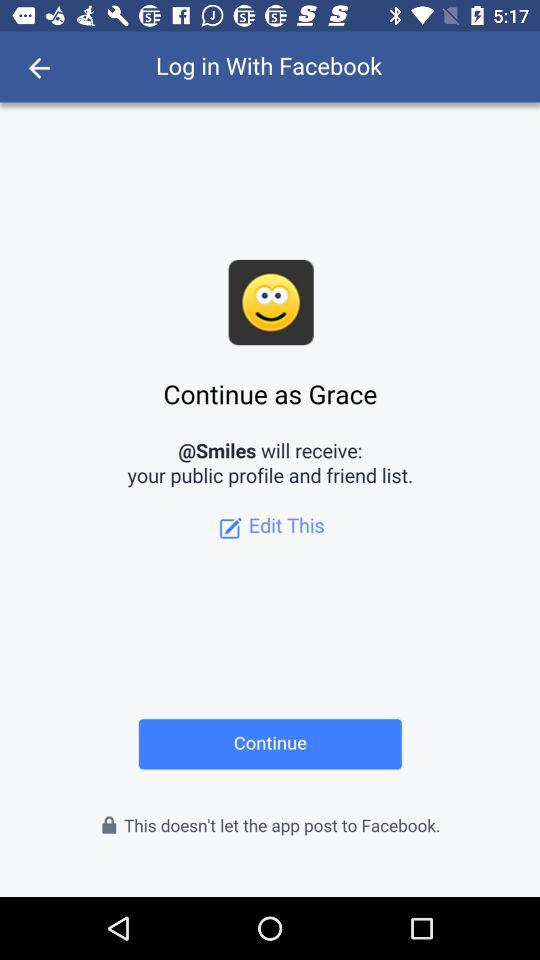What will "@Smiles" receive? "@Smiles" will receive your public profile and friend list. 